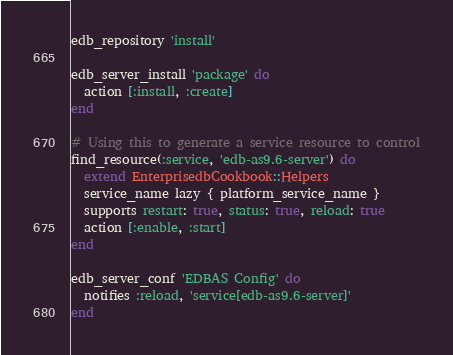<code> <loc_0><loc_0><loc_500><loc_500><_Ruby_>edb_repository 'install'

edb_server_install 'package' do
  action [:install, :create]
end

# Using this to generate a service resource to control
find_resource(:service, 'edb-as9.6-server') do
  extend EnterprisedbCookbook::Helpers
  service_name lazy { platform_service_name }
  supports restart: true, status: true, reload: true
  action [:enable, :start]
end

edb_server_conf 'EDBAS Config' do
  notifies :reload, 'service[edb-as9.6-server]'
end
</code> 